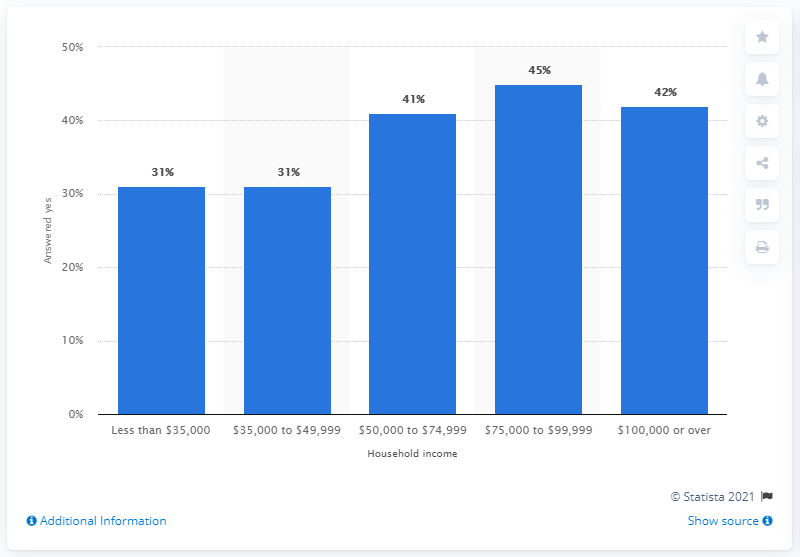Mention a couple of crucial points in this snapshot. Thirty-one percent of respondents with a household income between 35,000 and 49,999 U.S. dollars reported following Major League Baseball, according to the survey. 